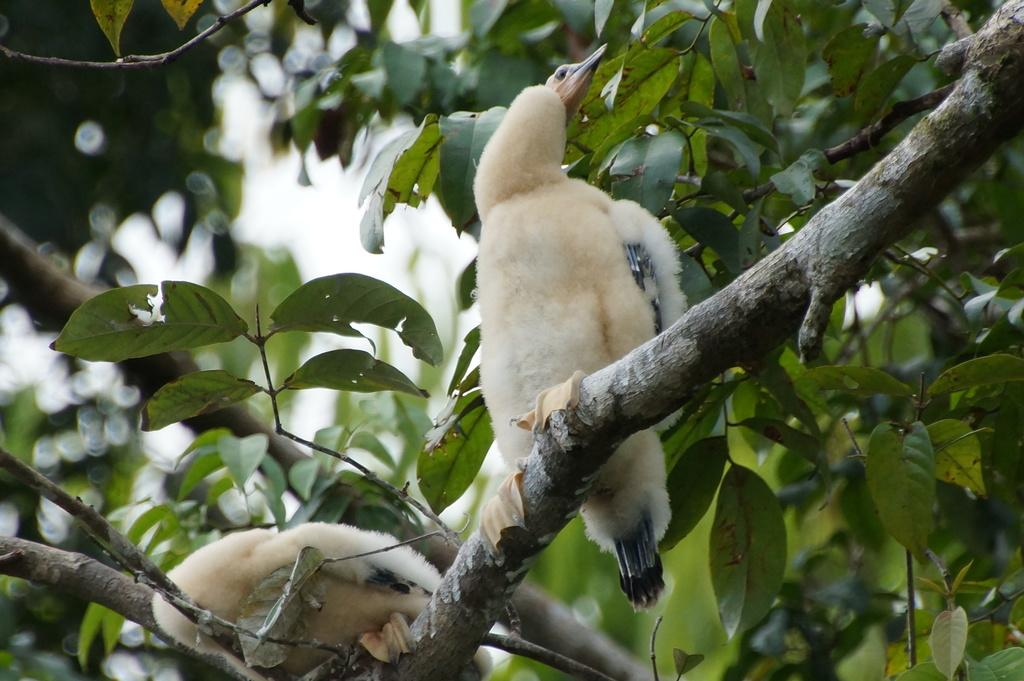What type of animals can be seen in the image? There are two white color birds in the image. Where are the birds located in the image? The birds are on the branches of a tree. What part of the natural environment is visible in the image? The sky is visible in the image. What type of trousers are the birds wearing in the image? Birds do not wear trousers, so this question cannot be answered based on the image. 